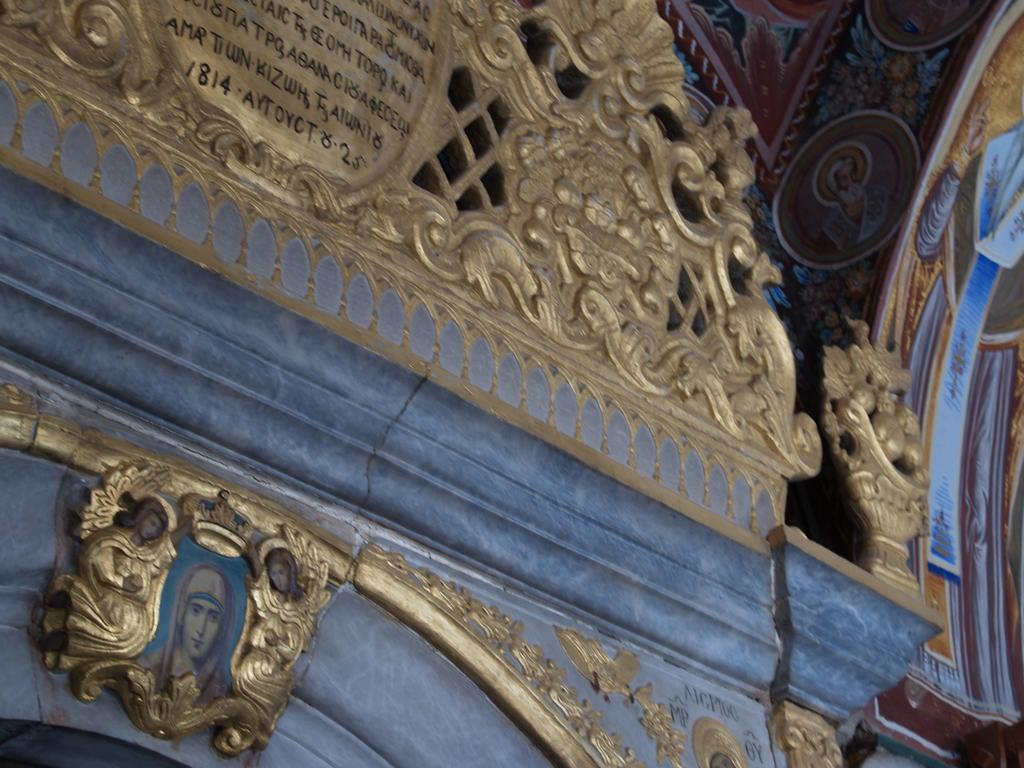What is on the wall in the image? There is a wall with carvings in the image. What else can be seen on the wall besides the carvings? There are paintings of pictures on the wall and a picture frame. Is there any text on the wall? Yes, there is text on the wall. Can you describe the wrist of the stranger in the image? There is no stranger present in the image, so it is not possible to describe their wrist. 